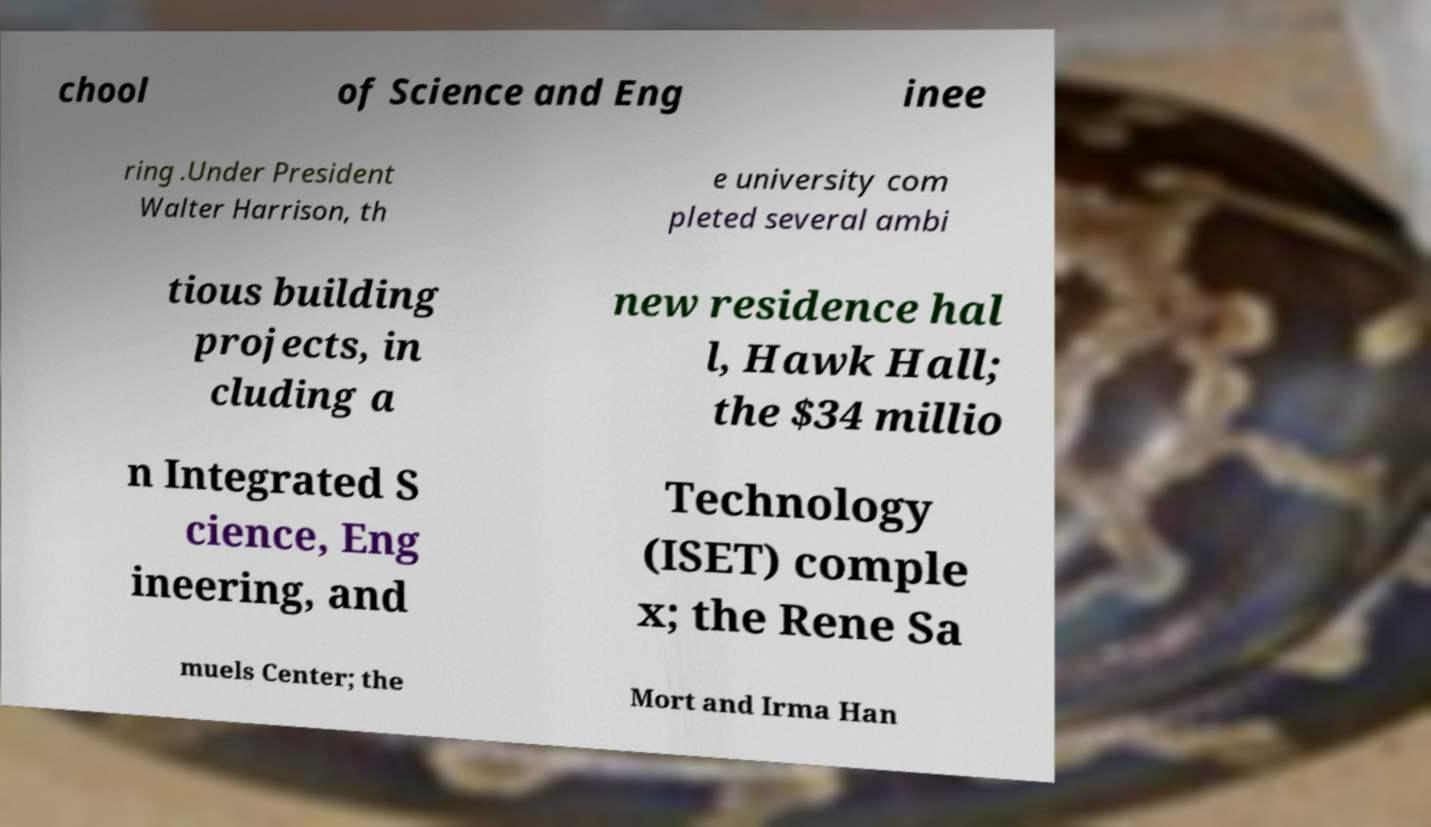What messages or text are displayed in this image? I need them in a readable, typed format. chool of Science and Eng inee ring .Under President Walter Harrison, th e university com pleted several ambi tious building projects, in cluding a new residence hal l, Hawk Hall; the $34 millio n Integrated S cience, Eng ineering, and Technology (ISET) comple x; the Rene Sa muels Center; the Mort and Irma Han 